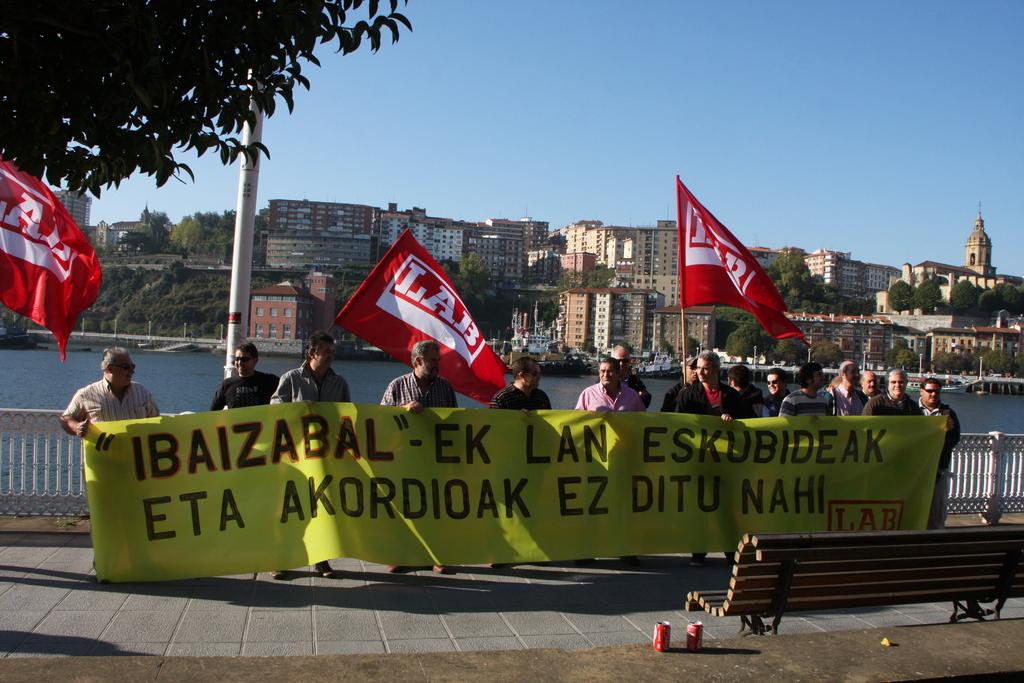How many people are in the group that is visible in the image? There is a group of people in the image, but the exact number is not specified. What are the people holding in the image? The people are holding a banner in the image. What type of furniture is present in the image? There is a bench in the image. What type of containers can be seen in the image? There are tins in the image. What type of decorations are present in the image? There are flags in the image. What type of natural feature can be seen in the image? There is water visible in the image. What type of man-made structures are present in the image? There are buildings in the image. What is visible in the background of the image? The sky is visible in the background of the image. What type of trees can be seen in the image? There are no trees visible in the image. What type of light is emitted from the banner in the image? The banner in the image does not emit any light. 